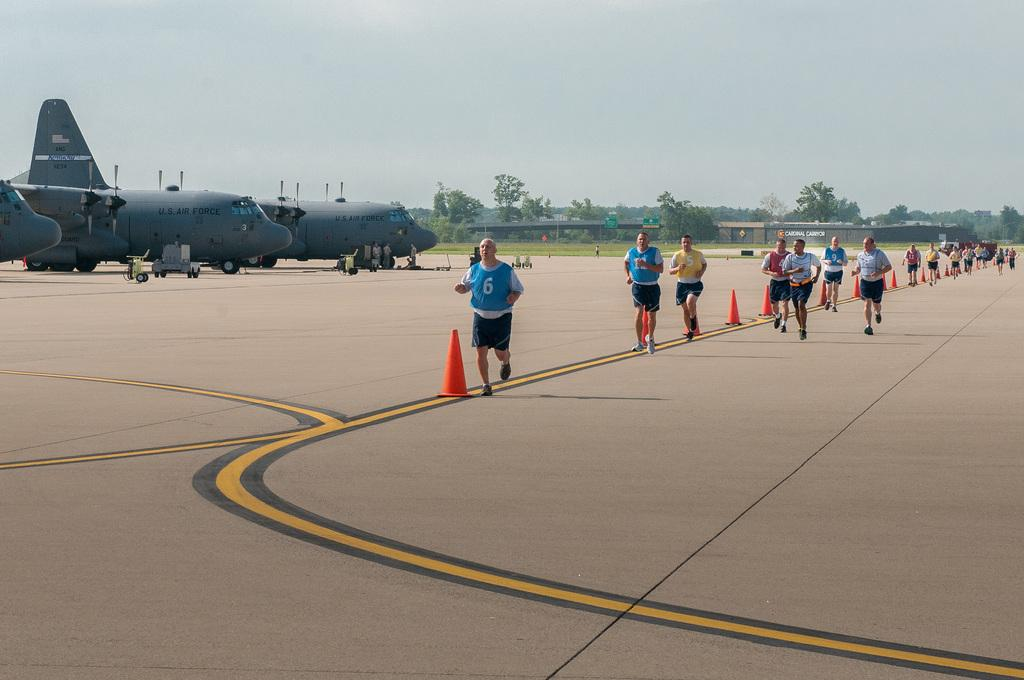<image>
Summarize the visual content of the image. In a long line of runners, the man in the lead has the number 6 on his shirt. 